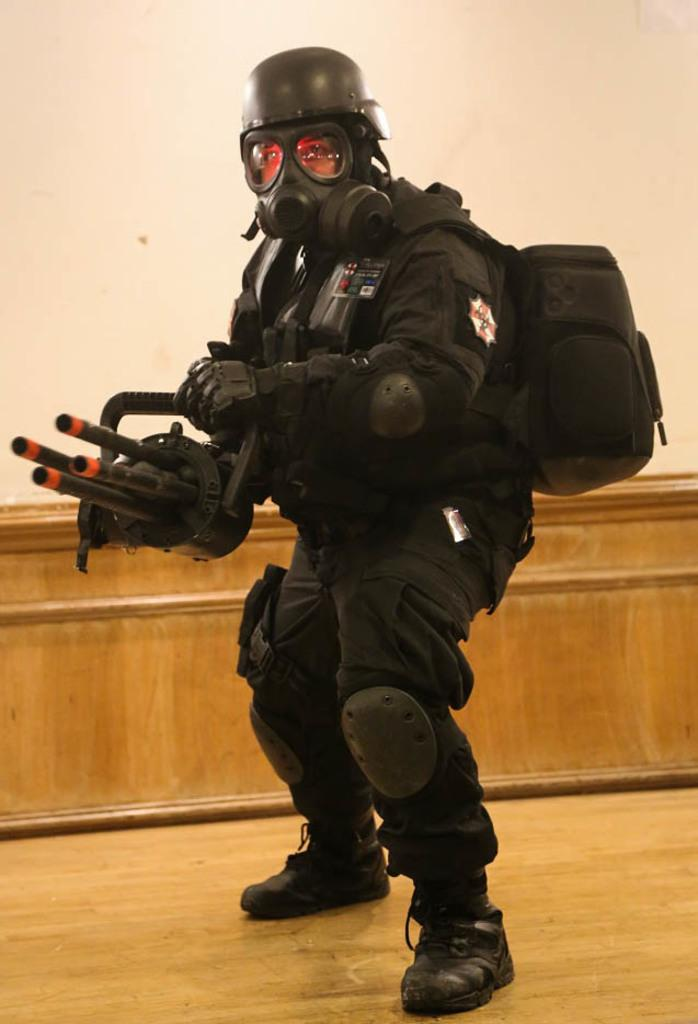Who is present in the image? There is a man in the image. What is the man wearing? The man is wearing a black dress. What accessory is the man carrying? The man is wearing a backpack. What is the man holding in his hands? The man is holding an object in his hands. What can be seen in the background of the image? There is a cream-colored wall in the background of the image. What type of ear is visible on the man in the image? There is no ear visible on the man in the image; he is wearing a black dress that covers his ears. 